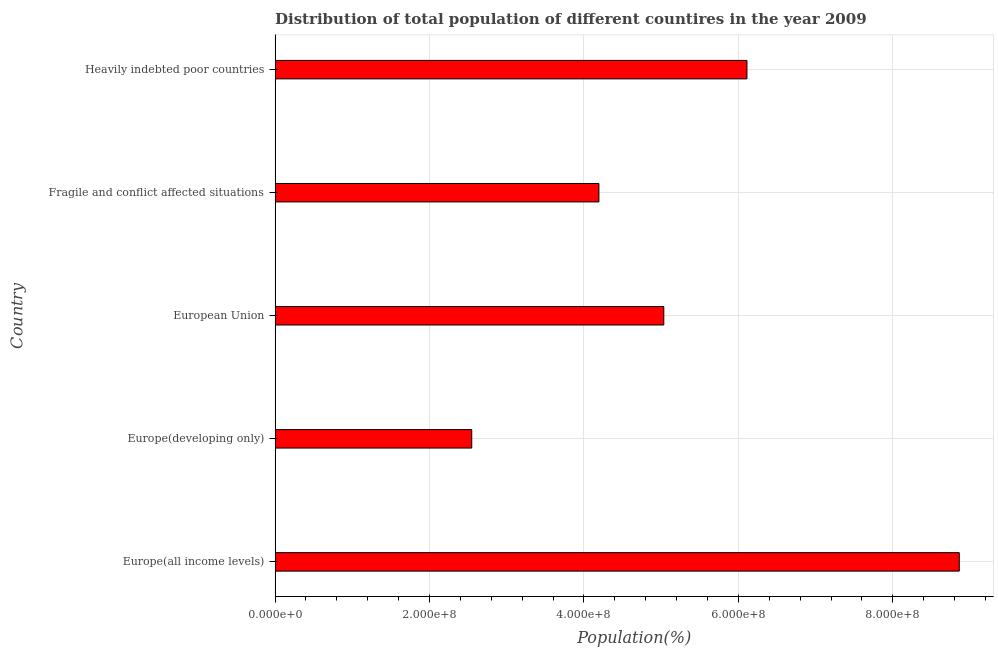Does the graph contain any zero values?
Ensure brevity in your answer.  No. What is the title of the graph?
Your answer should be very brief. Distribution of total population of different countires in the year 2009. What is the label or title of the X-axis?
Offer a terse response. Population(%). What is the label or title of the Y-axis?
Ensure brevity in your answer.  Country. What is the population in Heavily indebted poor countries?
Offer a terse response. 6.11e+08. Across all countries, what is the maximum population?
Give a very brief answer. 8.86e+08. Across all countries, what is the minimum population?
Keep it short and to the point. 2.55e+08. In which country was the population maximum?
Your response must be concise. Europe(all income levels). In which country was the population minimum?
Your answer should be compact. Europe(developing only). What is the sum of the population?
Provide a short and direct response. 2.67e+09. What is the difference between the population in Fragile and conflict affected situations and Heavily indebted poor countries?
Keep it short and to the point. -1.92e+08. What is the average population per country?
Your answer should be very brief. 5.35e+08. What is the median population?
Your response must be concise. 5.03e+08. What is the ratio of the population in Europe(all income levels) to that in Heavily indebted poor countries?
Your answer should be very brief. 1.45. What is the difference between the highest and the second highest population?
Your response must be concise. 2.75e+08. Is the sum of the population in Europe(all income levels) and European Union greater than the maximum population across all countries?
Ensure brevity in your answer.  Yes. What is the difference between the highest and the lowest population?
Provide a short and direct response. 6.31e+08. In how many countries, is the population greater than the average population taken over all countries?
Offer a very short reply. 2. How many countries are there in the graph?
Your answer should be very brief. 5. What is the difference between two consecutive major ticks on the X-axis?
Give a very brief answer. 2.00e+08. What is the Population(%) in Europe(all income levels)?
Your response must be concise. 8.86e+08. What is the Population(%) in Europe(developing only)?
Offer a very short reply. 2.55e+08. What is the Population(%) of European Union?
Make the answer very short. 5.03e+08. What is the Population(%) of Fragile and conflict affected situations?
Your answer should be very brief. 4.19e+08. What is the Population(%) of Heavily indebted poor countries?
Offer a very short reply. 6.11e+08. What is the difference between the Population(%) in Europe(all income levels) and Europe(developing only)?
Keep it short and to the point. 6.31e+08. What is the difference between the Population(%) in Europe(all income levels) and European Union?
Make the answer very short. 3.83e+08. What is the difference between the Population(%) in Europe(all income levels) and Fragile and conflict affected situations?
Provide a succinct answer. 4.67e+08. What is the difference between the Population(%) in Europe(all income levels) and Heavily indebted poor countries?
Offer a terse response. 2.75e+08. What is the difference between the Population(%) in Europe(developing only) and European Union?
Provide a succinct answer. -2.49e+08. What is the difference between the Population(%) in Europe(developing only) and Fragile and conflict affected situations?
Offer a terse response. -1.65e+08. What is the difference between the Population(%) in Europe(developing only) and Heavily indebted poor countries?
Provide a short and direct response. -3.56e+08. What is the difference between the Population(%) in European Union and Fragile and conflict affected situations?
Give a very brief answer. 8.40e+07. What is the difference between the Population(%) in European Union and Heavily indebted poor countries?
Your answer should be very brief. -1.08e+08. What is the difference between the Population(%) in Fragile and conflict affected situations and Heavily indebted poor countries?
Your response must be concise. -1.92e+08. What is the ratio of the Population(%) in Europe(all income levels) to that in Europe(developing only)?
Your answer should be compact. 3.48. What is the ratio of the Population(%) in Europe(all income levels) to that in European Union?
Your answer should be compact. 1.76. What is the ratio of the Population(%) in Europe(all income levels) to that in Fragile and conflict affected situations?
Provide a succinct answer. 2.11. What is the ratio of the Population(%) in Europe(all income levels) to that in Heavily indebted poor countries?
Give a very brief answer. 1.45. What is the ratio of the Population(%) in Europe(developing only) to that in European Union?
Keep it short and to the point. 0.51. What is the ratio of the Population(%) in Europe(developing only) to that in Fragile and conflict affected situations?
Your answer should be compact. 0.61. What is the ratio of the Population(%) in Europe(developing only) to that in Heavily indebted poor countries?
Offer a very short reply. 0.42. What is the ratio of the Population(%) in European Union to that in Heavily indebted poor countries?
Make the answer very short. 0.82. What is the ratio of the Population(%) in Fragile and conflict affected situations to that in Heavily indebted poor countries?
Give a very brief answer. 0.69. 